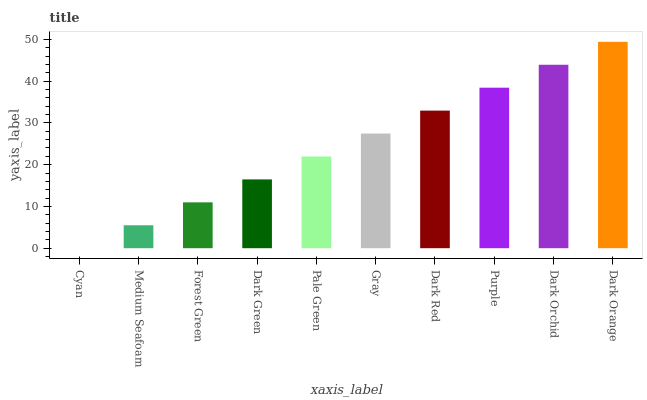Is Cyan the minimum?
Answer yes or no. Yes. Is Dark Orange the maximum?
Answer yes or no. Yes. Is Medium Seafoam the minimum?
Answer yes or no. No. Is Medium Seafoam the maximum?
Answer yes or no. No. Is Medium Seafoam greater than Cyan?
Answer yes or no. Yes. Is Cyan less than Medium Seafoam?
Answer yes or no. Yes. Is Cyan greater than Medium Seafoam?
Answer yes or no. No. Is Medium Seafoam less than Cyan?
Answer yes or no. No. Is Gray the high median?
Answer yes or no. Yes. Is Pale Green the low median?
Answer yes or no. Yes. Is Purple the high median?
Answer yes or no. No. Is Dark Orchid the low median?
Answer yes or no. No. 